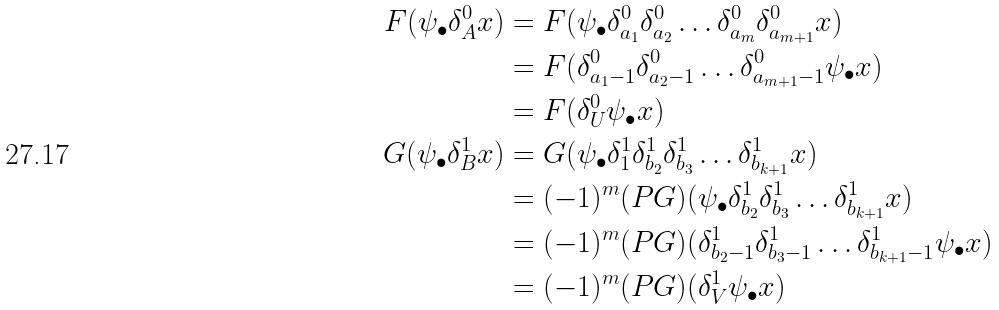<formula> <loc_0><loc_0><loc_500><loc_500>F ( \psi _ { \bullet } \delta ^ { 0 } _ { A } x ) & = F ( \psi _ { \bullet } \delta ^ { 0 } _ { a _ { 1 } } \delta ^ { 0 } _ { a _ { 2 } } \dots \delta ^ { 0 } _ { a _ { m } } \delta ^ { 0 } _ { a _ { m + 1 } } x ) \\ & = F ( \delta ^ { 0 } _ { a _ { 1 } - 1 } \delta ^ { 0 } _ { a _ { 2 } - 1 } \dots \delta ^ { 0 } _ { a _ { m + 1 } - 1 } \psi _ { \bullet } x ) \\ & = F ( \delta ^ { 0 } _ { U } \psi _ { \bullet } x ) \\ G ( \psi _ { \bullet } \delta ^ { 1 } _ { B } x ) & = G ( \psi _ { \bullet } \delta ^ { 1 } _ { 1 } \delta ^ { 1 } _ { b _ { 2 } } \delta ^ { 1 } _ { b _ { 3 } } \dots \delta ^ { 1 } _ { b _ { k + 1 } } x ) \\ & = ( - 1 ) ^ { m } ( P G ) ( \psi _ { \bullet } \delta ^ { 1 } _ { b _ { 2 } } \delta ^ { 1 } _ { b _ { 3 } } \dots \delta ^ { 1 } _ { b _ { k + 1 } } x ) \\ & = ( - 1 ) ^ { m } ( P G ) ( \delta ^ { 1 } _ { b _ { 2 } - 1 } \delta ^ { 1 } _ { b _ { 3 } - 1 } \dots \delta ^ { 1 } _ { b _ { k + 1 } - 1 } \psi _ { \bullet } x ) \\ & = ( - 1 ) ^ { m } ( P G ) ( \delta ^ { 1 } _ { V } \psi _ { \bullet } x )</formula> 